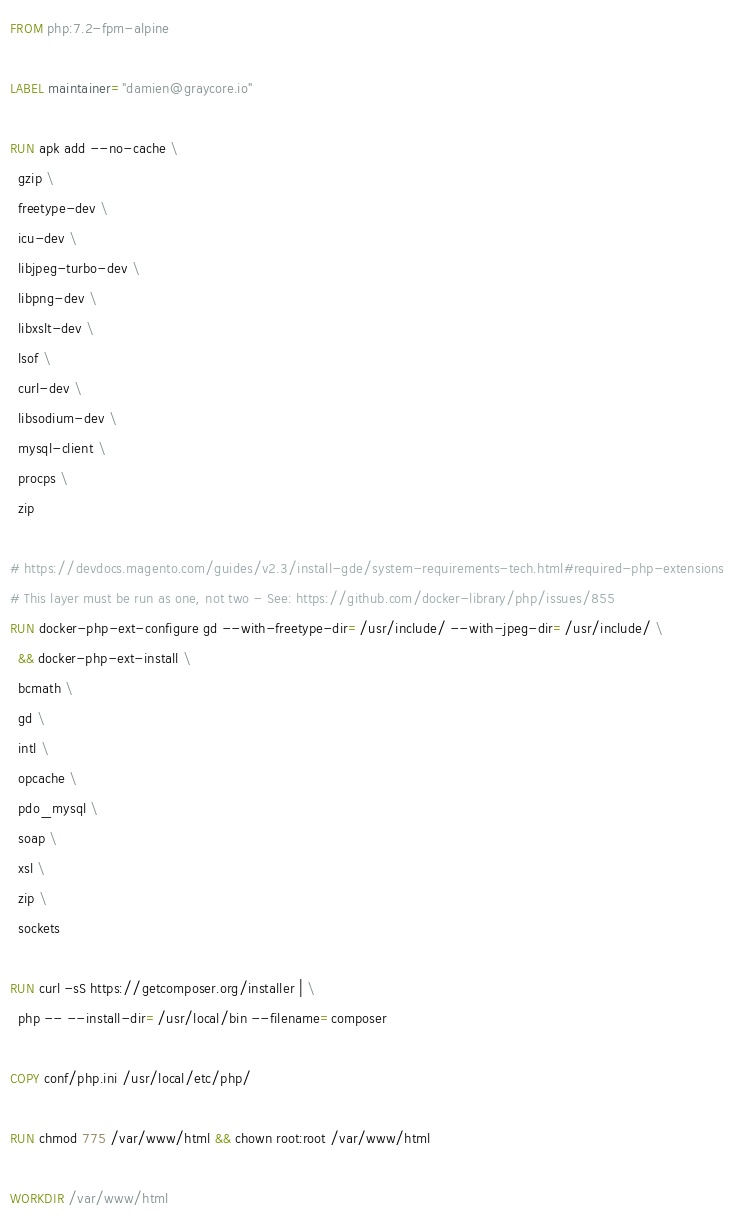<code> <loc_0><loc_0><loc_500><loc_500><_Dockerfile_>FROM php:7.2-fpm-alpine

LABEL maintainer="damien@graycore.io"

RUN apk add --no-cache \
  gzip \
  freetype-dev \
  icu-dev \
  libjpeg-turbo-dev \
  libpng-dev \
  libxslt-dev \
  lsof \
  curl-dev \
  libsodium-dev \
  mysql-client \
  procps \
  zip

# https://devdocs.magento.com/guides/v2.3/install-gde/system-requirements-tech.html#required-php-extensions
# This layer must be run as one, not two - See: https://github.com/docker-library/php/issues/855
RUN docker-php-ext-configure gd --with-freetype-dir=/usr/include/ --with-jpeg-dir=/usr/include/ \
  && docker-php-ext-install \
  bcmath \
  gd \
  intl \
  opcache \
  pdo_mysql \
  soap \
  xsl \
  zip \
  sockets

RUN curl -sS https://getcomposer.org/installer | \
  php -- --install-dir=/usr/local/bin --filename=composer

COPY conf/php.ini /usr/local/etc/php/

RUN chmod 775 /var/www/html && chown root:root /var/www/html

WORKDIR /var/www/html</code> 